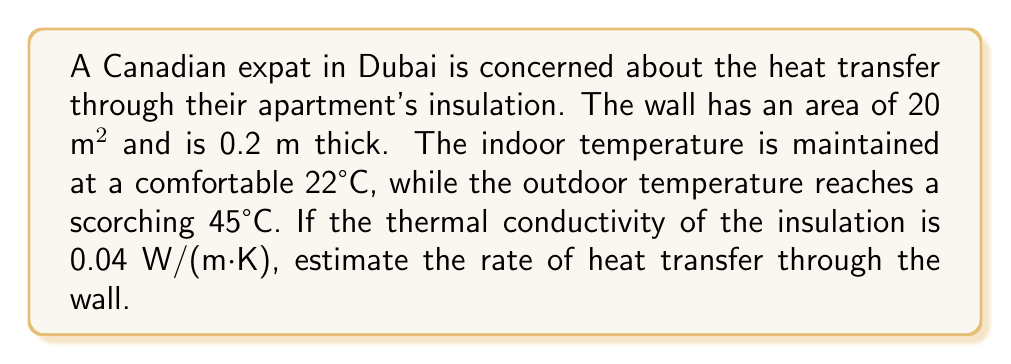What is the answer to this math problem? To solve this problem, we'll use Fourier's Law of Heat Conduction:

$$Q = -kA\frac{dT}{dx}$$

Where:
- $Q$ is the rate of heat transfer (W)
- $k$ is the thermal conductivity (W/(m·K))
- $A$ is the area of the wall (m²)
- $\frac{dT}{dx}$ is the temperature gradient (K/m)

Steps:

1. Identify given values:
   - $k = 0.04$ W/(m·K)
   - $A = 20$ m²
   - $\Delta T = 45°C - 22°C = 23°C = 23$ K
   - $\Delta x = 0.2$ m

2. Calculate the temperature gradient:
   $$\frac{dT}{dx} = \frac{\Delta T}{\Delta x} = \frac{23}{0.2} = 115$ K/m

3. Apply Fourier's Law:
   $$Q = -kA\frac{dT}{dx}$$
   $$Q = -(0.04)(20)(115)$$
   $$Q = -92$ W

4. The negative sign indicates heat flow from hot to cold (outside to inside). We're interested in the magnitude, so:
   $$Q = 92$ W
Answer: 92 W 